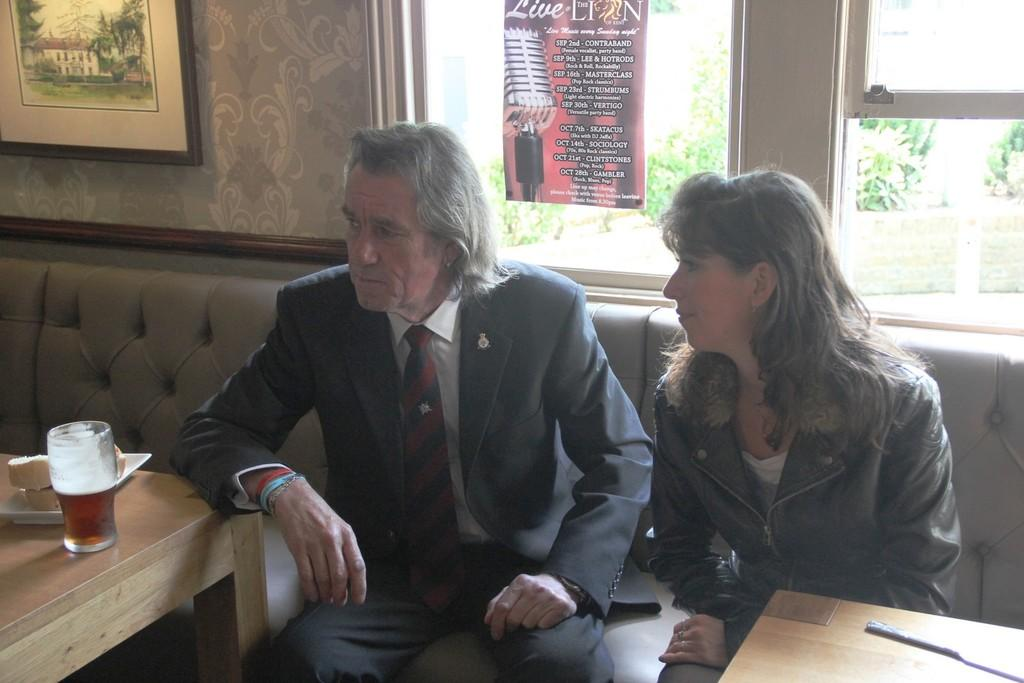How many people are in the image? There is a man and a woman in the image. What are the man and woman doing in the image? Both the man and woman are sitting on a couch. How many tables are visible in the image? There are two tables in the image. What objects can be seen on the tables? There is a glass and a plate on one of the tables. What is hanging on the wall in the image? There is a frame on the wall. What type of basket is being used by the man in the image? There is no basket present in the image. What kind of machine is being operated by the woman in the image? There is no machine present in the image. 